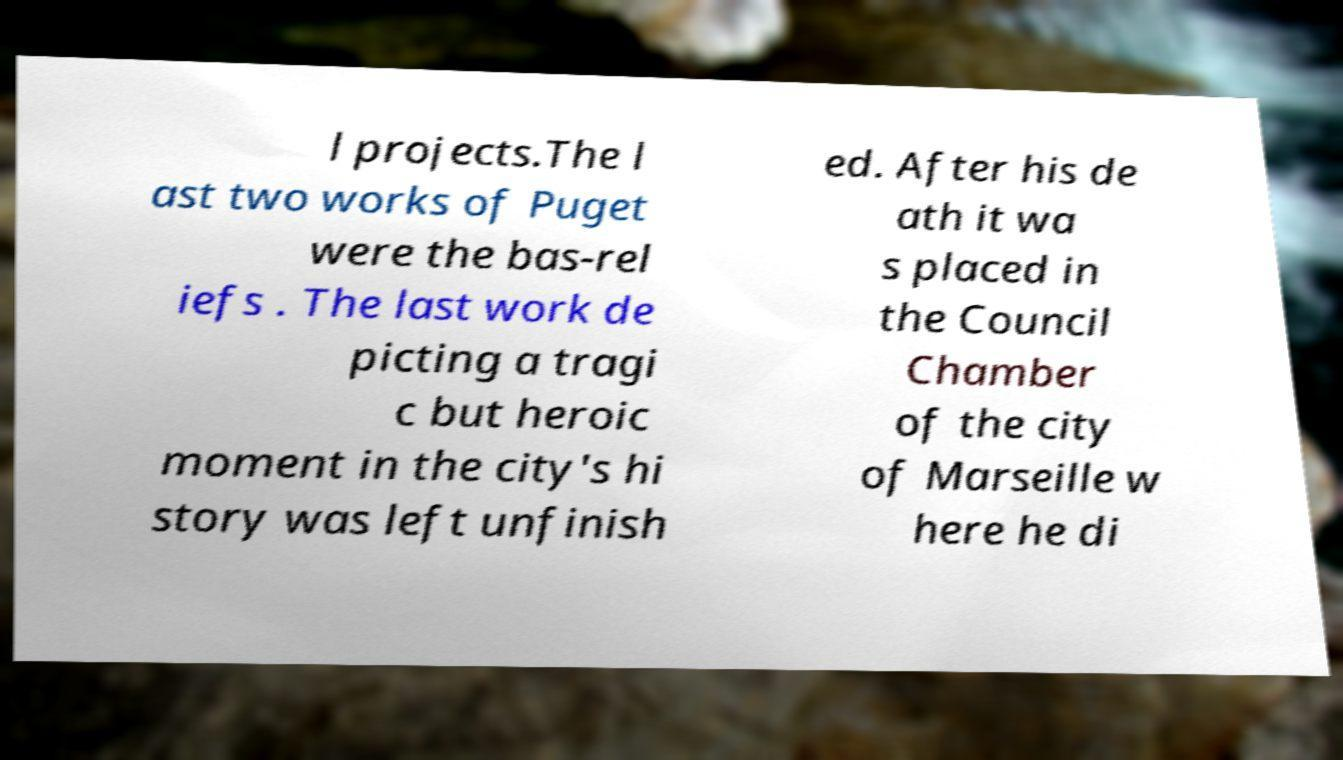For documentation purposes, I need the text within this image transcribed. Could you provide that? l projects.The l ast two works of Puget were the bas-rel iefs . The last work de picting a tragi c but heroic moment in the city's hi story was left unfinish ed. After his de ath it wa s placed in the Council Chamber of the city of Marseille w here he di 